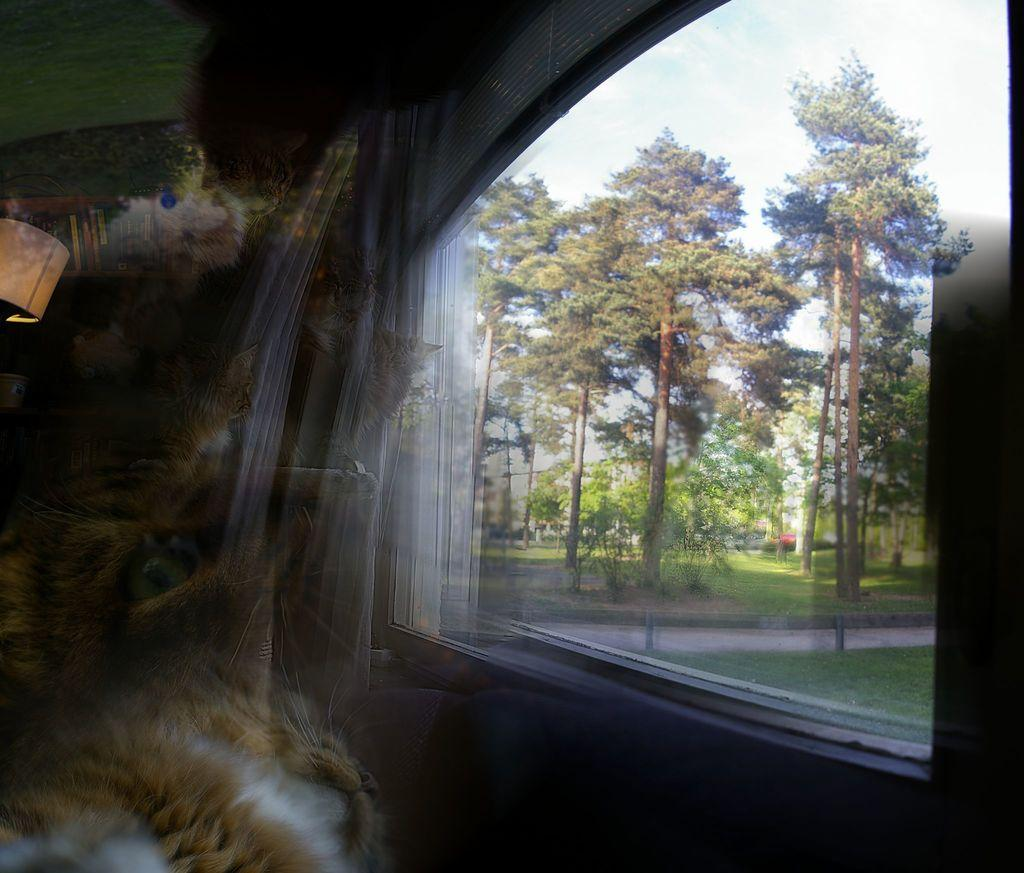What type of vehicle is in the image? The specific type of vehicle is not mentioned, but there is a vehicle present in the image. What natural elements can be seen in the image? Trees and grass are visible in the image. What man-made structure is in the image? There is a building in the image. What part of the natural environment is visible in the image? The sky is visible in the image. Where is the zebra located in the image? There is no zebra present in the image. What type of pan is being used to cook in the image? There is no pan or cooking activity present in the image. 